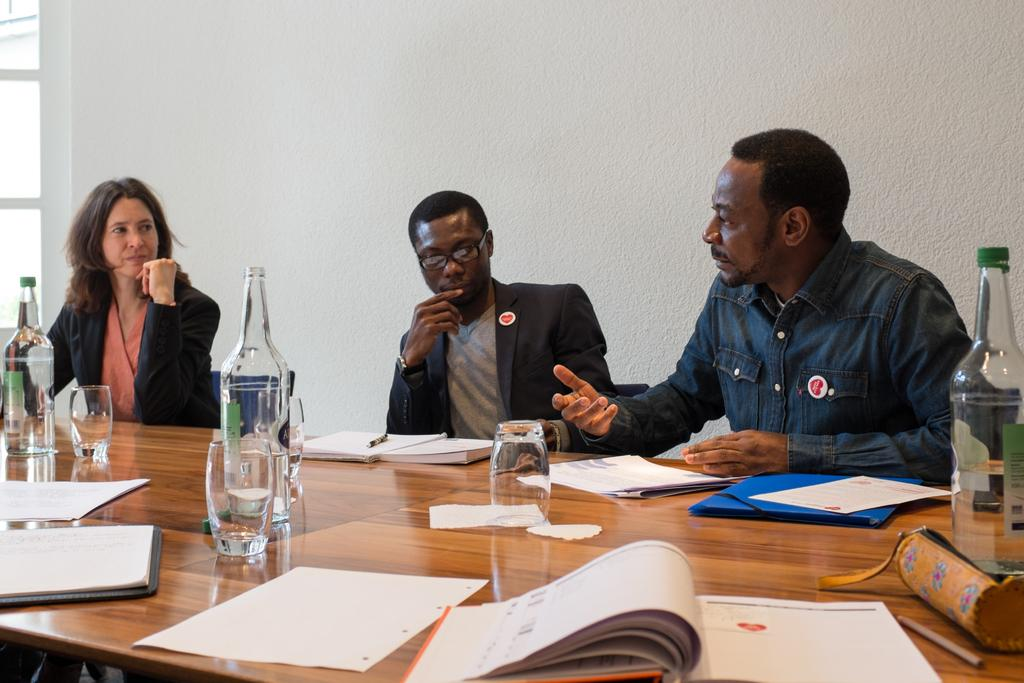How many people are sitting in front of the table in the image? There are three people sitting in front of the table in the image. What can be found on the table? There is a glass, bottles, and papers on the table. What is visible in the background of the image? There is a wall in the background of the image. Can you see a hen laying eggs on the table in the image? No, there is no hen or eggs present on the table in the image. What type of pen is being used by the people in the image? There is no pen visible in the image; only papers are mentioned on the table. 